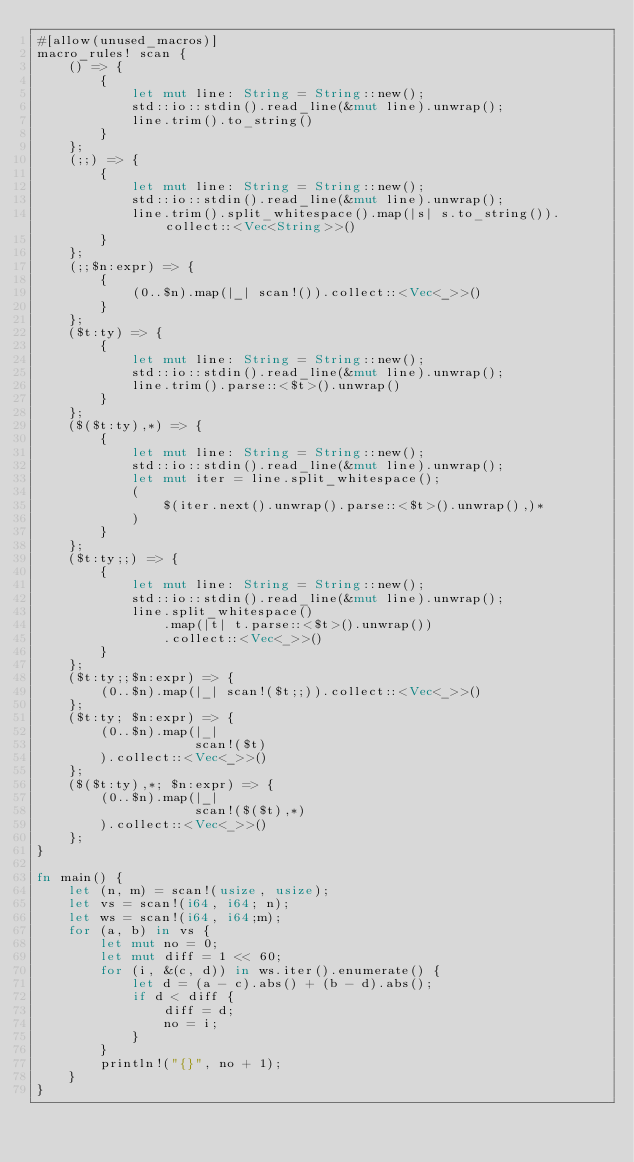<code> <loc_0><loc_0><loc_500><loc_500><_Rust_>#[allow(unused_macros)]
macro_rules! scan {
    () => {
        {
            let mut line: String = String::new();
            std::io::stdin().read_line(&mut line).unwrap();
            line.trim().to_string()
        }
    };
    (;;) => {
        {
            let mut line: String = String::new();
            std::io::stdin().read_line(&mut line).unwrap();
            line.trim().split_whitespace().map(|s| s.to_string()).collect::<Vec<String>>()
        }
    };
    (;;$n:expr) => {
        {
            (0..$n).map(|_| scan!()).collect::<Vec<_>>()
        }
    };
    ($t:ty) => {
        {
            let mut line: String = String::new();
            std::io::stdin().read_line(&mut line).unwrap();
            line.trim().parse::<$t>().unwrap()
        }
    };
    ($($t:ty),*) => {
        {
            let mut line: String = String::new();
            std::io::stdin().read_line(&mut line).unwrap();
            let mut iter = line.split_whitespace();
            (
                $(iter.next().unwrap().parse::<$t>().unwrap(),)*
            )
        }
    };
    ($t:ty;;) => {
        {
            let mut line: String = String::new();
            std::io::stdin().read_line(&mut line).unwrap();
            line.split_whitespace()
                .map(|t| t.parse::<$t>().unwrap())
                .collect::<Vec<_>>()
        }
    };
    ($t:ty;;$n:expr) => {
        (0..$n).map(|_| scan!($t;;)).collect::<Vec<_>>()
    };
    ($t:ty; $n:expr) => {
        (0..$n).map(|_|
                    scan!($t)
        ).collect::<Vec<_>>()
    };
    ($($t:ty),*; $n:expr) => {
        (0..$n).map(|_|
                    scan!($($t),*)
        ).collect::<Vec<_>>()
    };
}

fn main() {
    let (n, m) = scan!(usize, usize);
    let vs = scan!(i64, i64; n);
    let ws = scan!(i64, i64;m);
    for (a, b) in vs {
        let mut no = 0;
        let mut diff = 1 << 60;
        for (i, &(c, d)) in ws.iter().enumerate() {
            let d = (a - c).abs() + (b - d).abs();
            if d < diff {
                diff = d;
                no = i;
            }
        }
        println!("{}", no + 1);
    }
}
</code> 